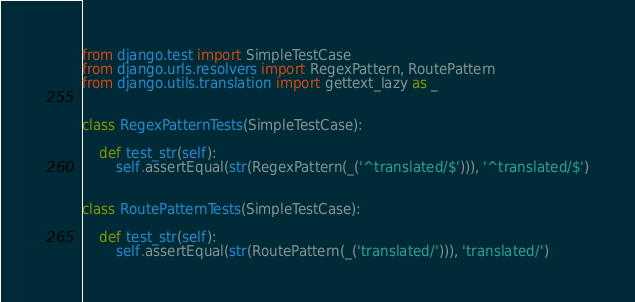Convert code to text. <code><loc_0><loc_0><loc_500><loc_500><_Python_>from django.test import SimpleTestCase
from django.urls.resolvers import RegexPattern, RoutePattern
from django.utils.translation import gettext_lazy as _


class RegexPatternTests(SimpleTestCase):

    def test_str(self):
        self.assertEqual(str(RegexPattern(_('^translated/$'))), '^translated/$')


class RoutePatternTests(SimpleTestCase):

    def test_str(self):
        self.assertEqual(str(RoutePattern(_('translated/'))), 'translated/')
</code> 